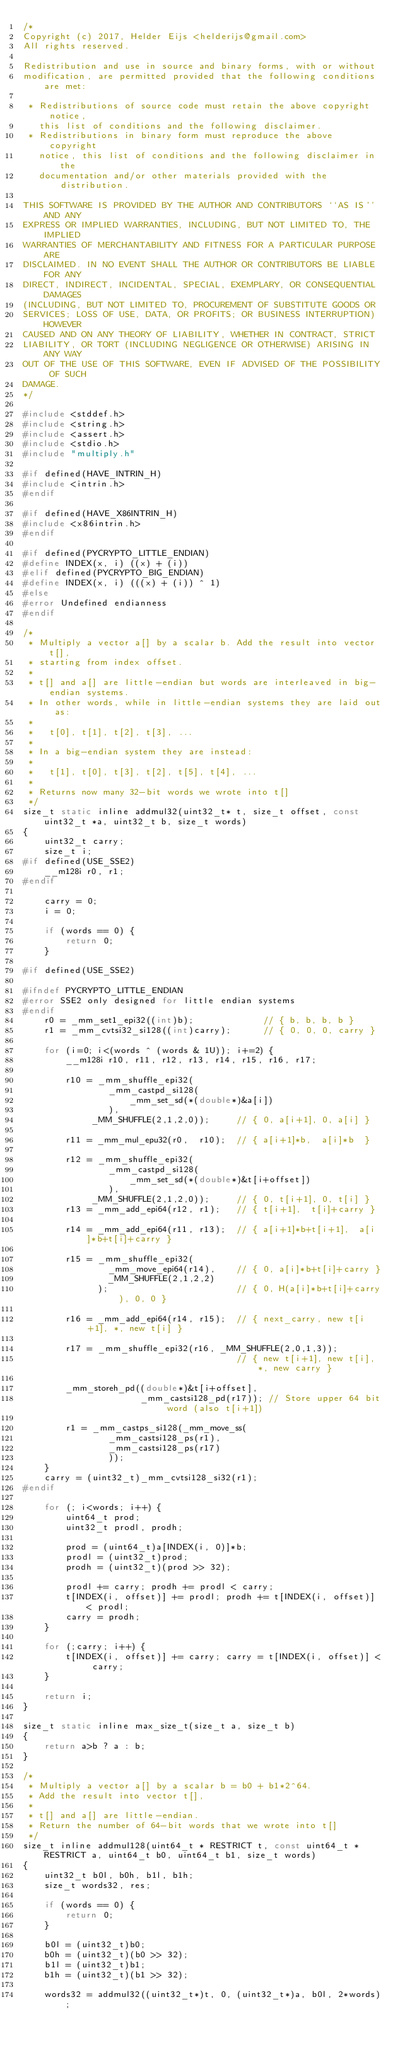Convert code to text. <code><loc_0><loc_0><loc_500><loc_500><_C_>/*
Copyright (c) 2017, Helder Eijs <helderijs@gmail.com>
All rights reserved.

Redistribution and use in source and binary forms, with or without
modification, are permitted provided that the following conditions are met:

 * Redistributions of source code must retain the above copyright notice,
   this list of conditions and the following disclaimer.
 * Redistributions in binary form must reproduce the above copyright
   notice, this list of conditions and the following disclaimer in the
   documentation and/or other materials provided with the distribution.

THIS SOFTWARE IS PROVIDED BY THE AUTHOR AND CONTRIBUTORS ``AS IS'' AND ANY
EXPRESS OR IMPLIED WARRANTIES, INCLUDING, BUT NOT LIMITED TO, THE IMPLIED
WARRANTIES OF MERCHANTABILITY AND FITNESS FOR A PARTICULAR PURPOSE ARE
DISCLAIMED. IN NO EVENT SHALL THE AUTHOR OR CONTRIBUTORS BE LIABLE FOR ANY
DIRECT, INDIRECT, INCIDENTAL, SPECIAL, EXEMPLARY, OR CONSEQUENTIAL DAMAGES
(INCLUDING, BUT NOT LIMITED TO, PROCUREMENT OF SUBSTITUTE GOODS OR
SERVICES; LOSS OF USE, DATA, OR PROFITS; OR BUSINESS INTERRUPTION) HOWEVER
CAUSED AND ON ANY THEORY OF LIABILITY, WHETHER IN CONTRACT, STRICT
LIABILITY, OR TORT (INCLUDING NEGLIGENCE OR OTHERWISE) ARISING IN ANY WAY
OUT OF THE USE OF THIS SOFTWARE, EVEN IF ADVISED OF THE POSSIBILITY OF SUCH
DAMAGE.
*/

#include <stddef.h>
#include <string.h>
#include <assert.h>
#include <stdio.h>
#include "multiply.h"

#if defined(HAVE_INTRIN_H)
#include <intrin.h>
#endif

#if defined(HAVE_X86INTRIN_H)
#include <x86intrin.h>
#endif

#if defined(PYCRYPTO_LITTLE_ENDIAN)
#define INDEX(x, i) ((x) + (i))
#elif defined(PYCRYPTO_BIG_ENDIAN) 
#define INDEX(x, i) (((x) + (i)) ^ 1)
#else
#error Undefined endianness
#endif

/*
 * Multiply a vector a[] by a scalar b. Add the result into vector t[],
 * starting from index offset.
 *
 * t[] and a[] are little-endian but words are interleaved in big-endian systems.
 * In other words, while in little-endian systems they are laid out as:
 *
 *   t[0], t[1], t[2], t[3], ...
 *
 * In a big-endian system they are instead:
 *
 *   t[1], t[0], t[3], t[2], t[5], t[4], ...
 *
 * Returns now many 32-bit words we wrote into t[]
 */
size_t static inline addmul32(uint32_t* t, size_t offset, const uint32_t *a, uint32_t b, size_t words)
{
    uint32_t carry;
    size_t i;
#if defined(USE_SSE2)
    __m128i r0, r1;
#endif

    carry = 0;
    i = 0;

    if (words == 0) {
        return 0;
    }

#if defined(USE_SSE2)

#ifndef PYCRYPTO_LITTLE_ENDIAN
#error SSE2 only designed for little endian systems
#endif
    r0 = _mm_set1_epi32((int)b);             // { b, b, b, b }
    r1 = _mm_cvtsi32_si128((int)carry);      // { 0, 0, 0, carry }

    for (i=0; i<(words ^ (words & 1U)); i+=2) {
        __m128i r10, r11, r12, r13, r14, r15, r16, r17;

        r10 = _mm_shuffle_epi32(
                _mm_castpd_si128(
                    _mm_set_sd(*(double*)&a[i])
                ),
             _MM_SHUFFLE(2,1,2,0));     // { 0, a[i+1], 0, a[i] }

        r11 = _mm_mul_epu32(r0,  r10);  // { a[i+1]*b,  a[i]*b  }

        r12 = _mm_shuffle_epi32(
                _mm_castpd_si128(
                    _mm_set_sd(*(double*)&t[i+offset])
                ),
             _MM_SHUFFLE(2,1,2,0));     // { 0, t[i+1], 0, t[i] }
        r13 = _mm_add_epi64(r12, r1);   // { t[i+1],  t[i]+carry }

        r14 = _mm_add_epi64(r11, r13);  // { a[i+1]*b+t[i+1],  a[i]*b+t[i]+carry }

        r15 = _mm_shuffle_epi32(
                _mm_move_epi64(r14),    // { 0, a[i]*b+t[i]+carry }
                _MM_SHUFFLE(2,1,2,2)
              );                        // { 0, H(a[i]*b+t[i]+carry), 0, 0 }

        r16 = _mm_add_epi64(r14, r15);  // { next_carry, new t[i+1], *, new t[i] }

        r17 = _mm_shuffle_epi32(r16, _MM_SHUFFLE(2,0,1,3));
                                        // { new t[i+1], new t[i], *, new carry }

        _mm_storeh_pd((double*)&t[i+offset],
                      _mm_castsi128_pd(r17)); // Store upper 64 bit word (also t[i+1])

        r1 = _mm_castps_si128(_mm_move_ss(
                _mm_castsi128_ps(r1),
                _mm_castsi128_ps(r17)
                ));
    }
    carry = (uint32_t)_mm_cvtsi128_si32(r1);
#endif

    for (; i<words; i++) {
        uint64_t prod;
        uint32_t prodl, prodh;

        prod = (uint64_t)a[INDEX(i, 0)]*b;
        prodl = (uint32_t)prod;
        prodh = (uint32_t)(prod >> 32);

        prodl += carry; prodh += prodl < carry;
        t[INDEX(i, offset)] += prodl; prodh += t[INDEX(i, offset)] < prodl;
        carry = prodh;
    }

    for (;carry; i++) {
        t[INDEX(i, offset)] += carry; carry = t[INDEX(i, offset)] < carry;
    }

    return i;
}

size_t static inline max_size_t(size_t a, size_t b)
{
    return a>b ? a : b;
}

/*
 * Multiply a vector a[] by a scalar b = b0 + b1*2^64.
 * Add the result into vector t[],
 *
 * t[] and a[] are little-endian.
 * Return the number of 64-bit words that we wrote into t[]
 */
size_t inline addmul128(uint64_t * RESTRICT t, const uint64_t * RESTRICT a, uint64_t b0, uint64_t b1, size_t words)
{
    uint32_t b0l, b0h, b1l, b1h;
    size_t words32, res;

    if (words == 0) {
        return 0;
    }

    b0l = (uint32_t)b0;
    b0h = (uint32_t)(b0 >> 32);
    b1l = (uint32_t)b1;
    b1h = (uint32_t)(b1 >> 32);

    words32 = addmul32((uint32_t*)t, 0, (uint32_t*)a, b0l, 2*words);
    </code> 